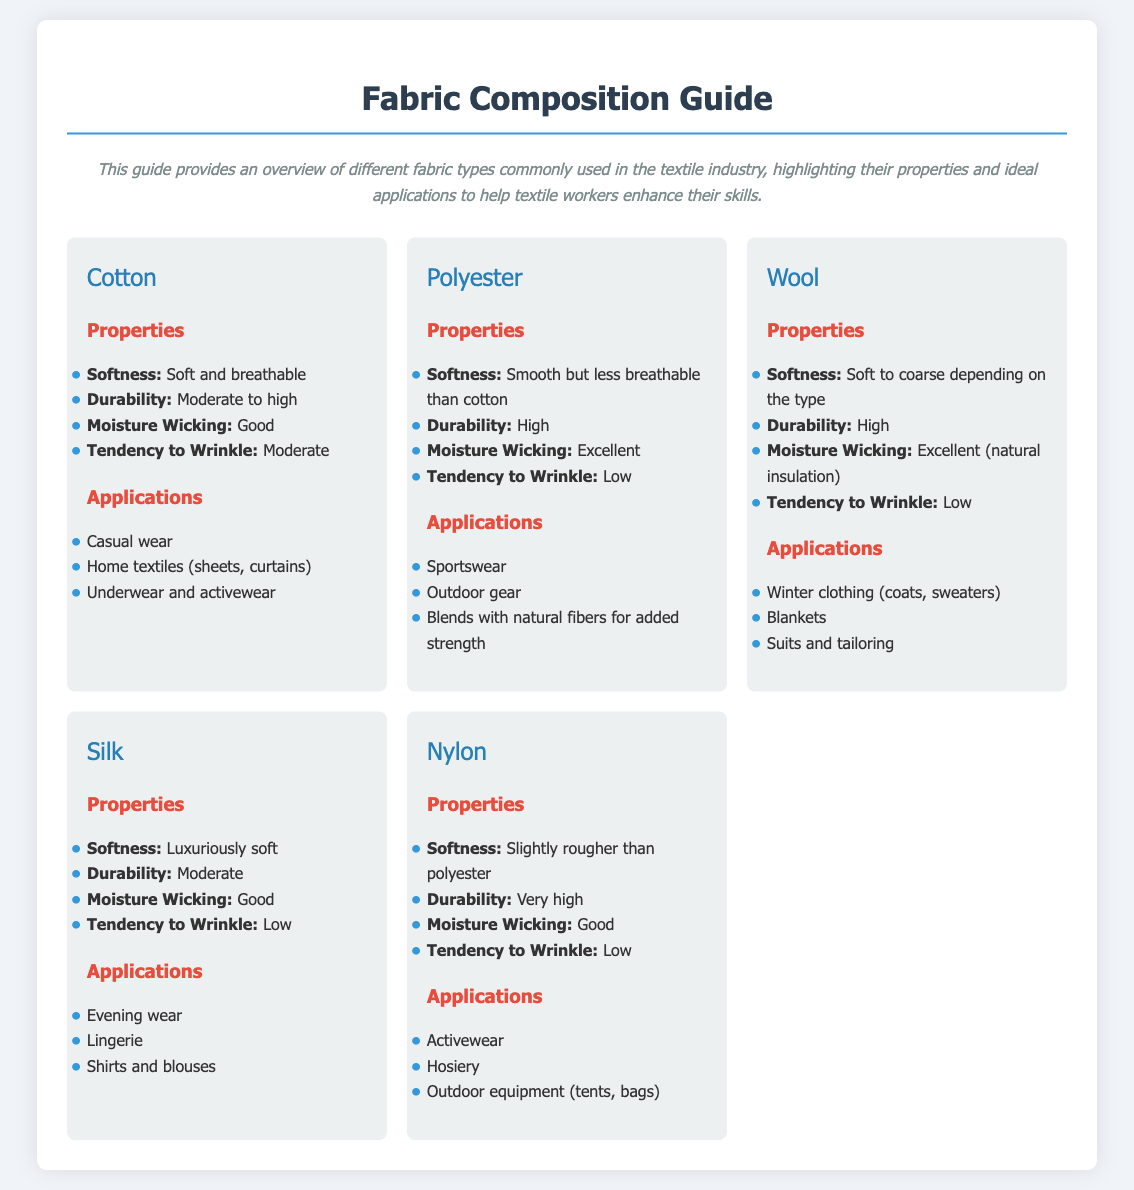what is the softness of Cotton? The softness of Cotton is described as soft and breathable in the document.
Answer: soft and breathable what is the durability rating of Polyester? The durability rating of Polyester is mentioned as high in the document.
Answer: high which fabric has excellent moisture wicking and low tendency to wrinkle? The fabric that has both excellent moisture wicking and low tendency to wrinkle is Wool.
Answer: Wool what are two applications of Silk? The applications of Silk listed include evening wear and lingerie.
Answer: evening wear, lingerie which fabric is commonly used for outdoor gear? The fabric commonly used for outdoor gear is Polyester.
Answer: Polyester what fabric has a softness described as luxuriously soft? The fabric with a softness described as luxuriously soft is Silk.
Answer: Silk which fabric has the highest durability? The fabric with the highest durability is Nylon.
Answer: Nylon how many fabrics are showcased in the guide? The guide showcases five different types of fabrics in total.
Answer: five what type of clothing is Wool used for? Wool is used for winter clothing, as stated in the document.
Answer: winter clothing 